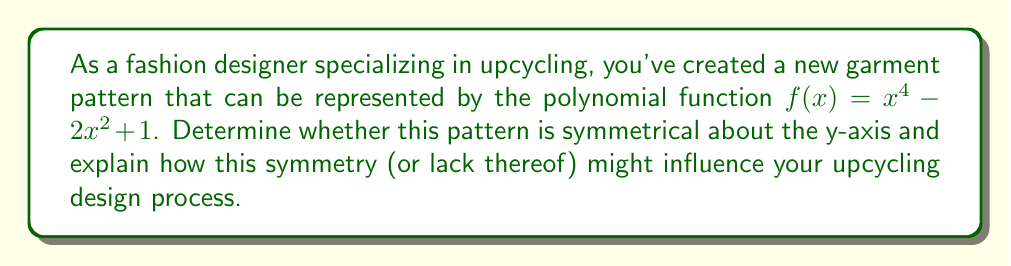Give your solution to this math problem. To determine if the polynomial function $f(x) = x^4 - 2x^2 + 1$ is symmetrical about the y-axis, we need to check if it's an even function. A function is even if $f(-x) = f(x)$ for all $x$ in the domain of $f$.

Let's evaluate $f(-x)$:

1) $f(-x) = (-x)^4 - 2(-x)^2 + 1$

2) Simplify:
   $f(-x) = x^4 - 2x^2 + 1$

3) Compare $f(-x)$ and $f(x)$:
   $f(-x) = x^4 - 2x^2 + 1 = f(x)$

Since $f(-x) = f(x)$, the function is even and therefore symmetrical about the y-axis.

In the context of upcycling design:
- This symmetry implies that the left and right sides of the garment pattern will be mirror images of each other when folded along the center (y-axis).
- Symmetrical patterns are often easier to work with when upcycling, as they allow for balanced designs and efficient use of fabric.
- The designer could use this symmetry to create matching elements on both sides of the garment or to ensure a balanced silhouette when transforming old garments.
Answer: Yes, symmetrical about y-axis; even function 